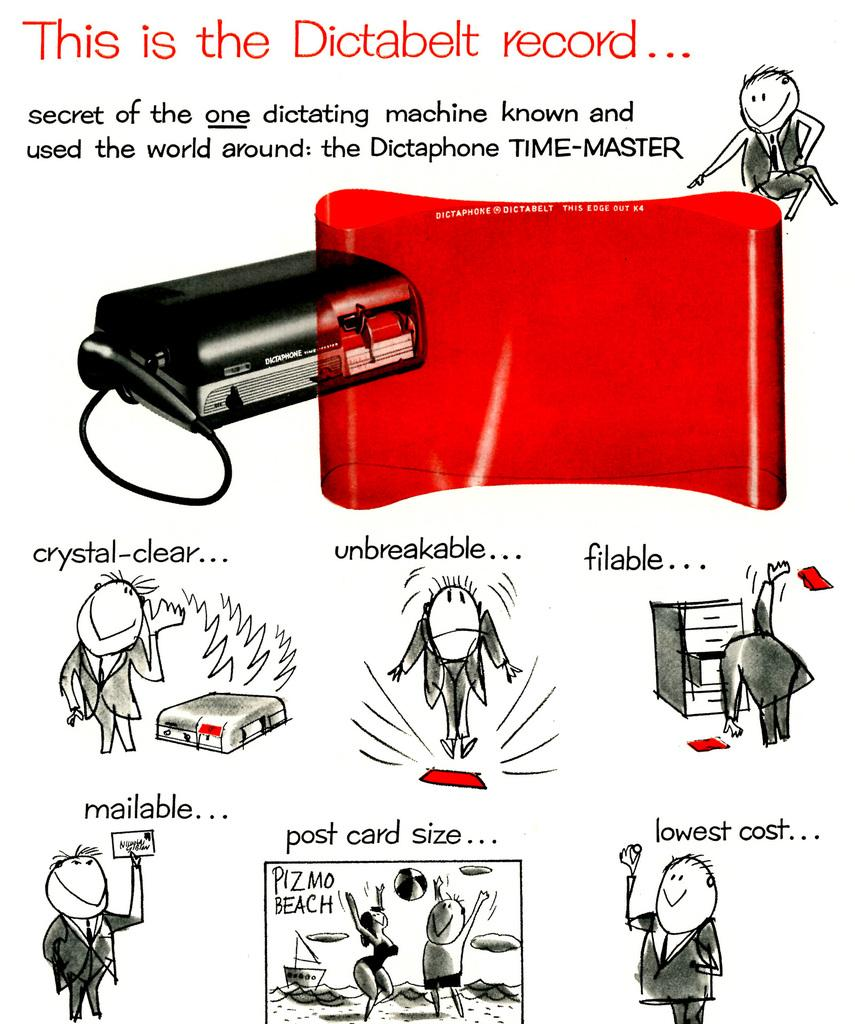Provide a one-sentence caption for the provided image. Poster that contains cartoons about the dictabelt record. 